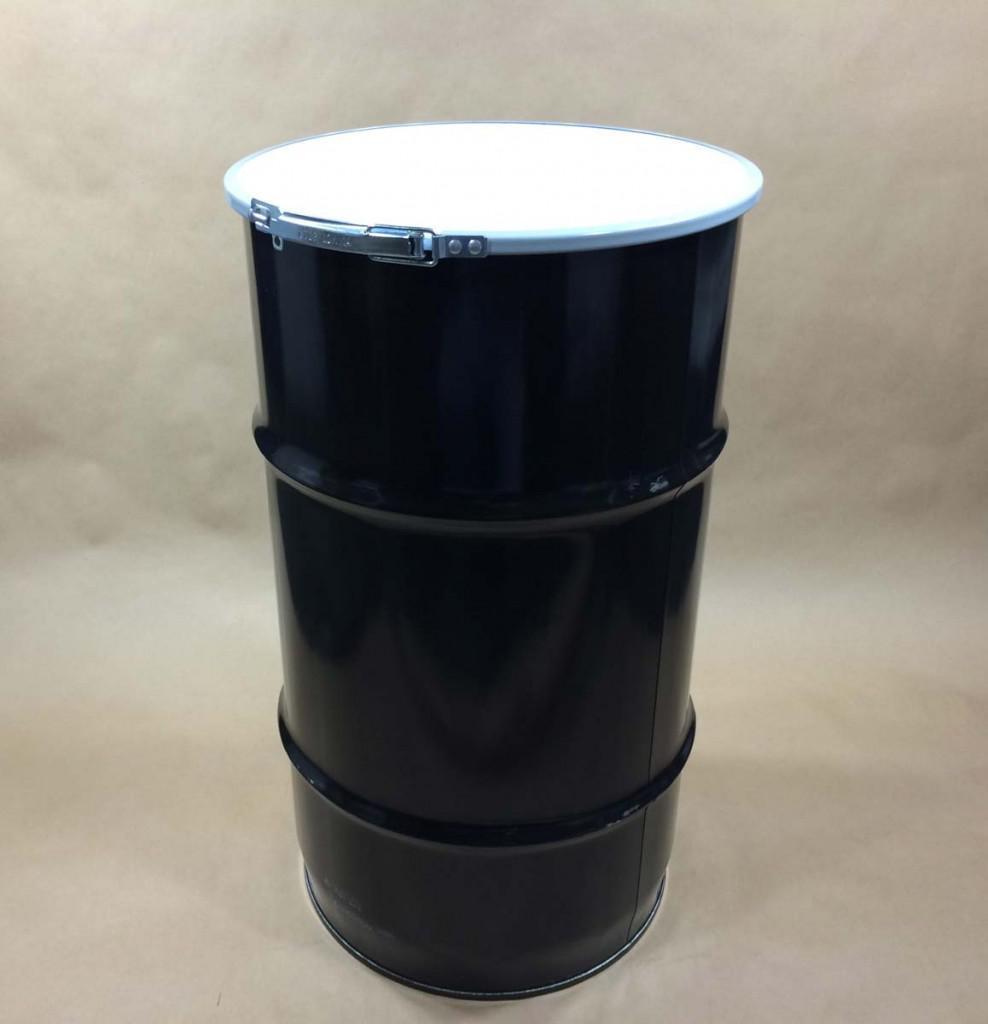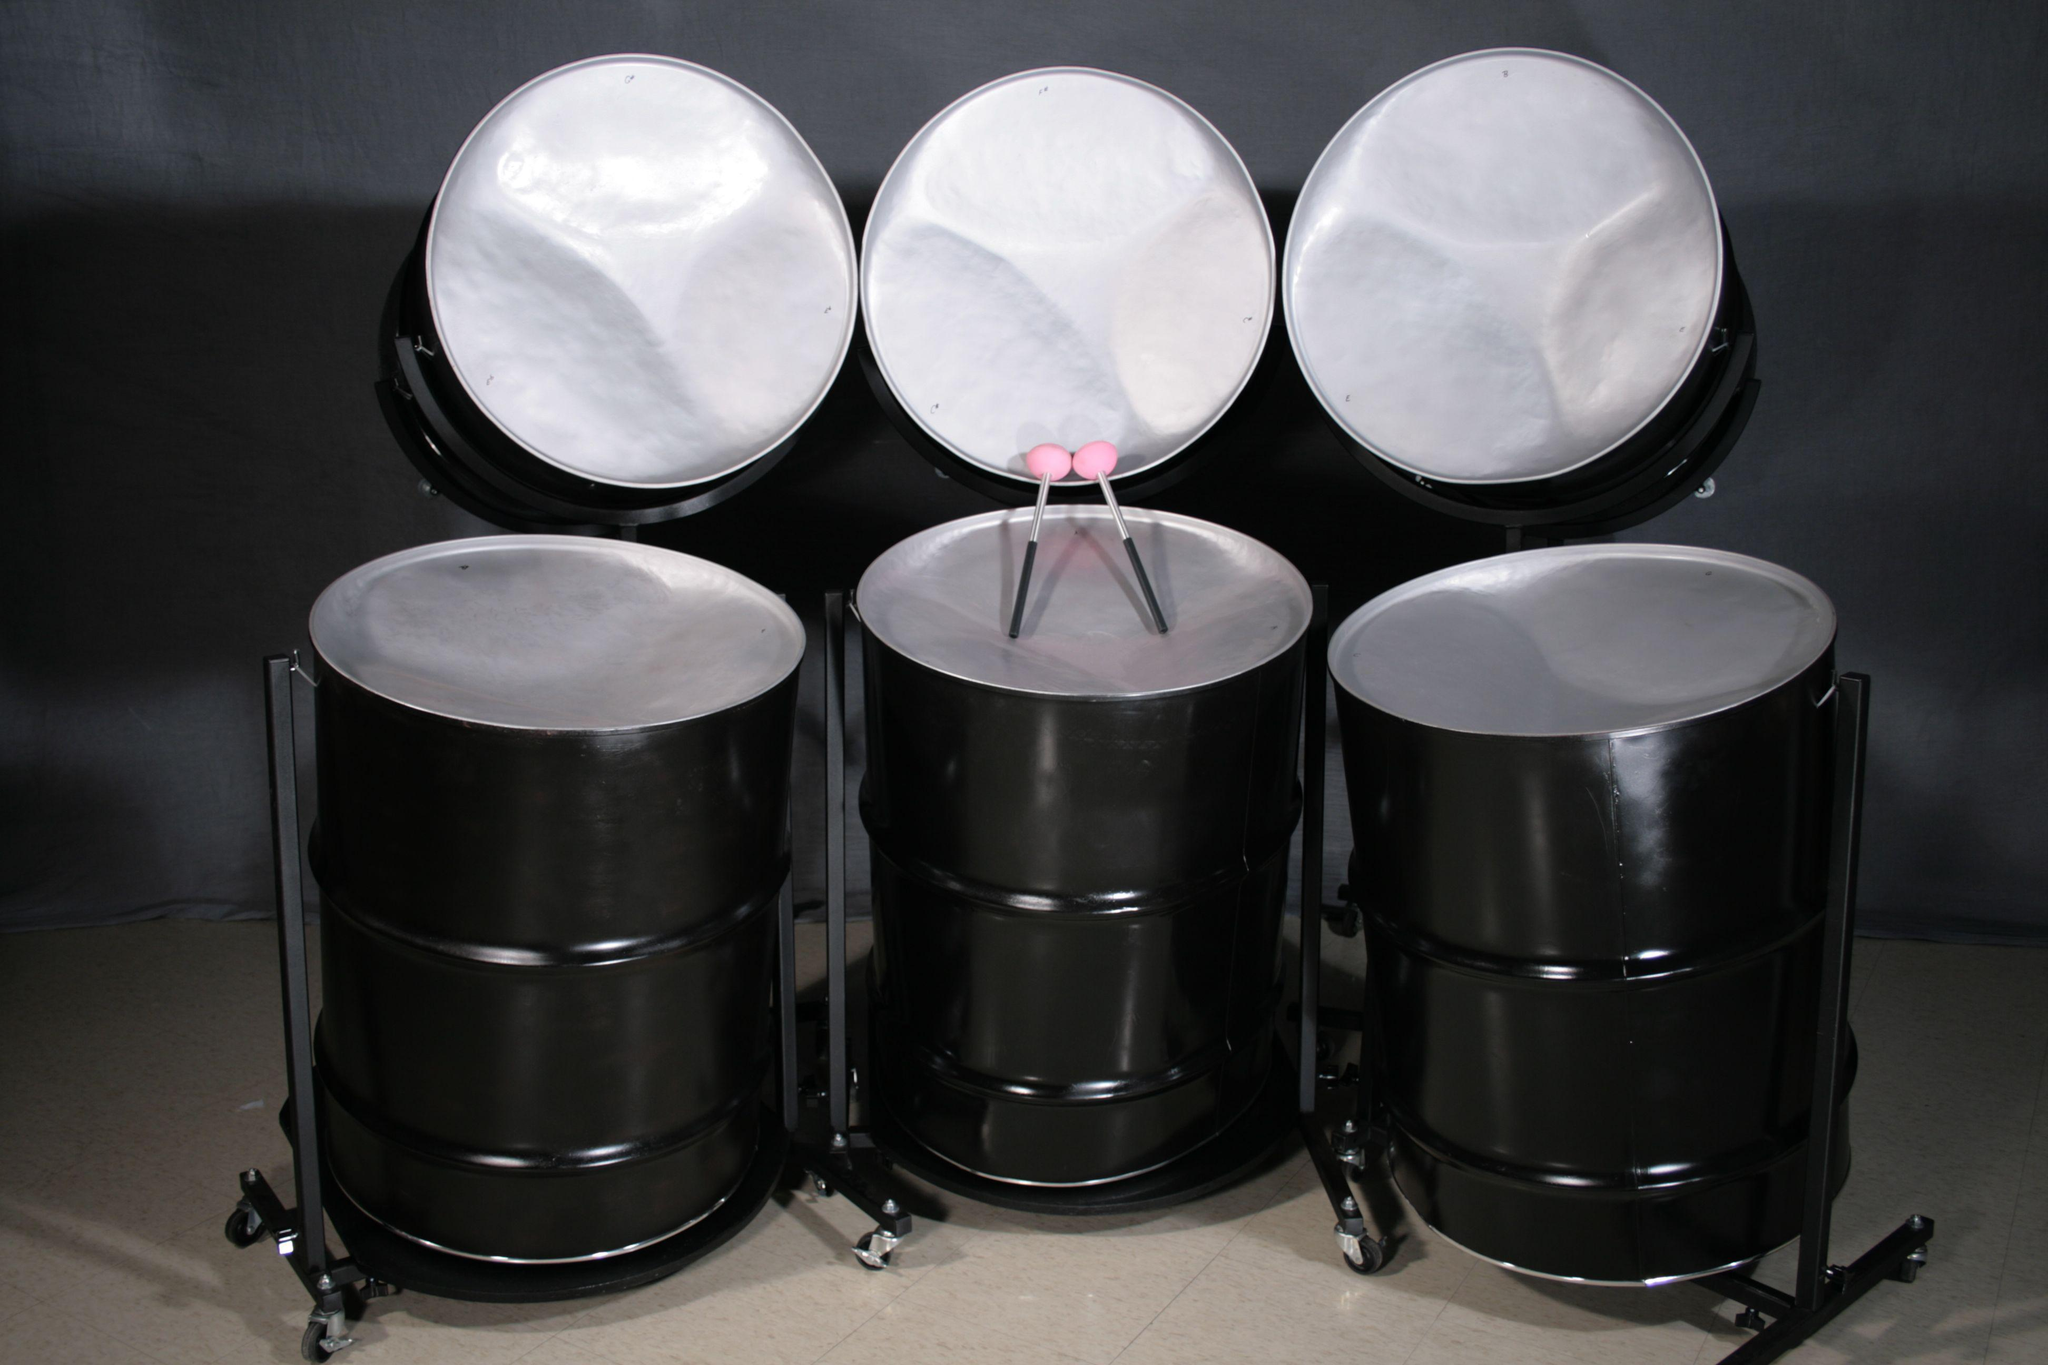The first image is the image on the left, the second image is the image on the right. Considering the images on both sides, is "The right image shows a pair of pink-tipped drumsticks resting on top of the middle of three upright black barrels, which stand in front of three non-upright black barrels." valid? Answer yes or no. Yes. The first image is the image on the left, the second image is the image on the right. Analyze the images presented: Is the assertion "There is one image that includes fewer than six drums." valid? Answer yes or no. Yes. 